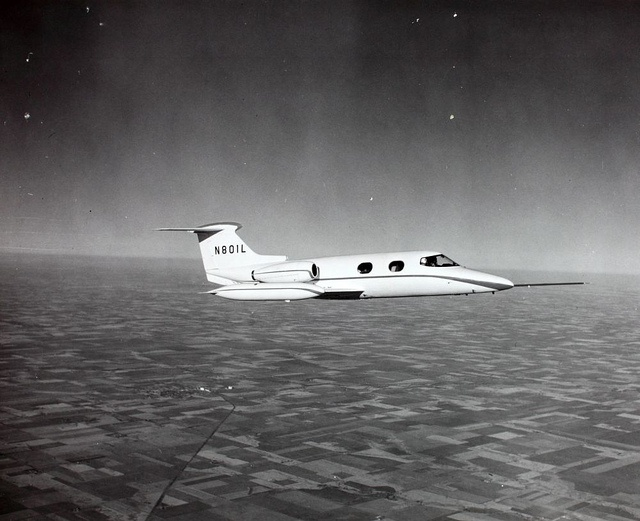Describe the objects in this image and their specific colors. I can see a airplane in black, white, darkgray, and gray tones in this image. 